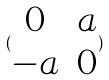Convert formula to latex. <formula><loc_0><loc_0><loc_500><loc_500>( \begin{matrix} 0 & a \\ - a & 0 \end{matrix} )</formula> 